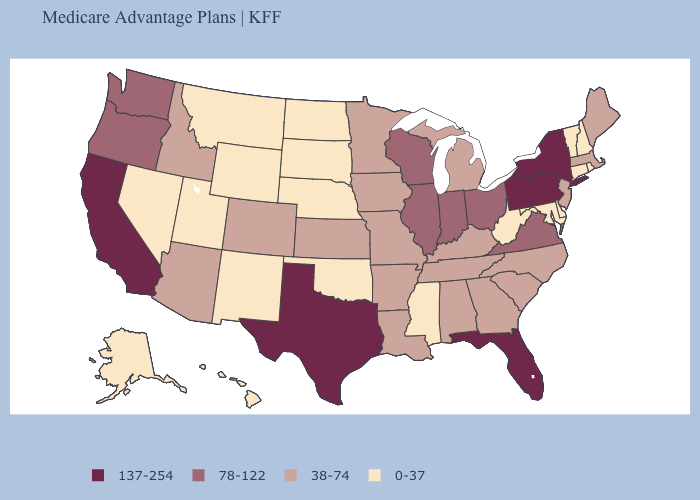Is the legend a continuous bar?
Quick response, please. No. Does Delaware have a lower value than New Mexico?
Give a very brief answer. No. Which states have the lowest value in the USA?
Give a very brief answer. Alaska, Connecticut, Delaware, Hawaii, Maryland, Mississippi, Montana, Nebraska, Nevada, New Hampshire, New Mexico, North Dakota, Oklahoma, Rhode Island, South Dakota, Utah, Vermont, West Virginia, Wyoming. Does the map have missing data?
Give a very brief answer. No. What is the value of Nebraska?
Keep it brief. 0-37. Does the map have missing data?
Short answer required. No. Does California have the highest value in the USA?
Quick response, please. Yes. What is the value of Wyoming?
Short answer required. 0-37. What is the lowest value in the USA?
Write a very short answer. 0-37. Which states have the lowest value in the MidWest?
Concise answer only. Nebraska, North Dakota, South Dakota. Is the legend a continuous bar?
Concise answer only. No. What is the value of Alaska?
Write a very short answer. 0-37. What is the value of Wisconsin?
Short answer required. 78-122. Name the states that have a value in the range 38-74?
Concise answer only. Alabama, Arizona, Arkansas, Colorado, Georgia, Idaho, Iowa, Kansas, Kentucky, Louisiana, Maine, Massachusetts, Michigan, Minnesota, Missouri, New Jersey, North Carolina, South Carolina, Tennessee. What is the lowest value in the MidWest?
Answer briefly. 0-37. 